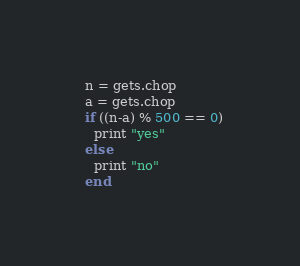Convert code to text. <code><loc_0><loc_0><loc_500><loc_500><_Ruby_>  n = gets.chop
  a = gets.chop
  if ((n-a) % 500 == 0)
    print "yes"
  else
    print "no"
  end</code> 